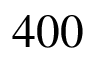<formula> <loc_0><loc_0><loc_500><loc_500>4 0 0</formula> 